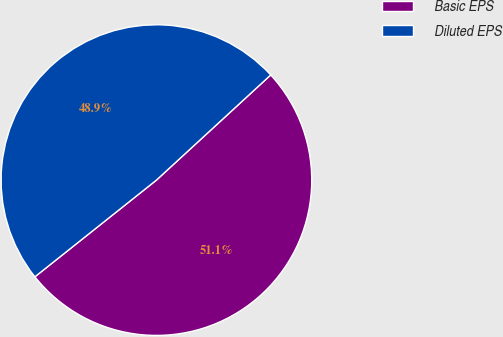Convert chart. <chart><loc_0><loc_0><loc_500><loc_500><pie_chart><fcel>Basic EPS<fcel>Diluted EPS<nl><fcel>51.14%<fcel>48.86%<nl></chart> 